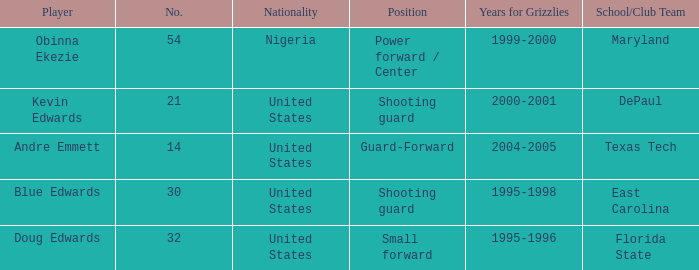When was the school/club team for grizzles was maryland 1999-2000. 